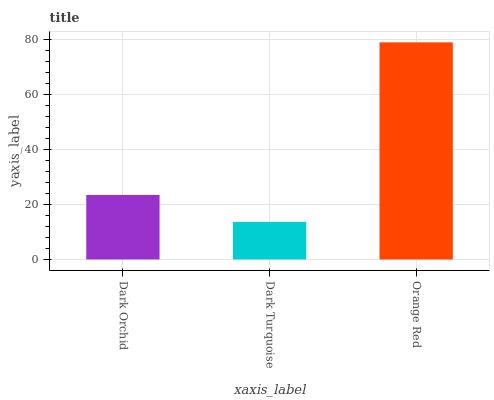Is Dark Turquoise the minimum?
Answer yes or no. Yes. Is Orange Red the maximum?
Answer yes or no. Yes. Is Orange Red the minimum?
Answer yes or no. No. Is Dark Turquoise the maximum?
Answer yes or no. No. Is Orange Red greater than Dark Turquoise?
Answer yes or no. Yes. Is Dark Turquoise less than Orange Red?
Answer yes or no. Yes. Is Dark Turquoise greater than Orange Red?
Answer yes or no. No. Is Orange Red less than Dark Turquoise?
Answer yes or no. No. Is Dark Orchid the high median?
Answer yes or no. Yes. Is Dark Orchid the low median?
Answer yes or no. Yes. Is Orange Red the high median?
Answer yes or no. No. Is Dark Turquoise the low median?
Answer yes or no. No. 